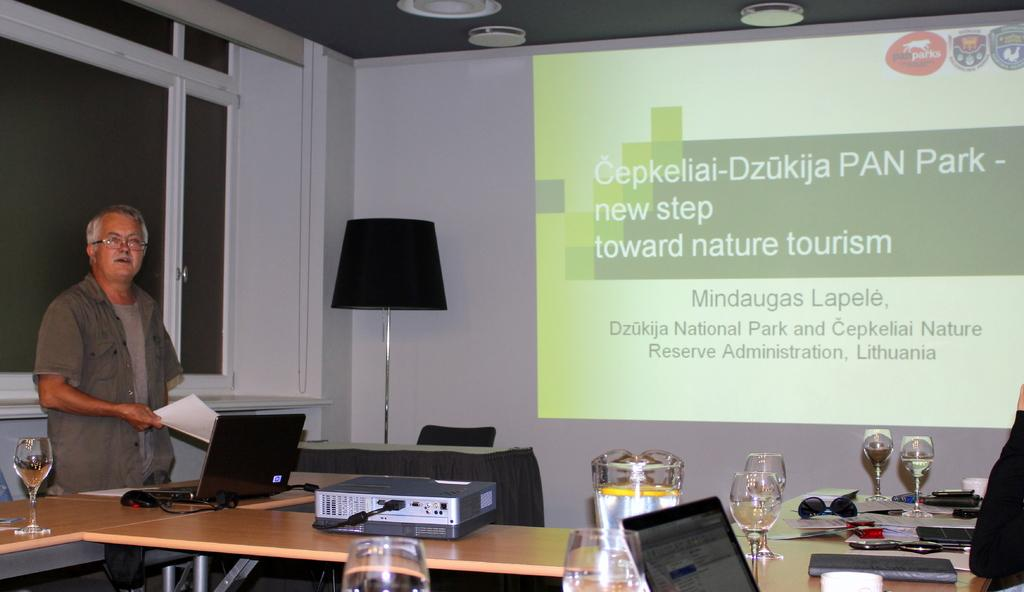<image>
Provide a brief description of the given image. Projector displaying information about a national park in Lithuania. 